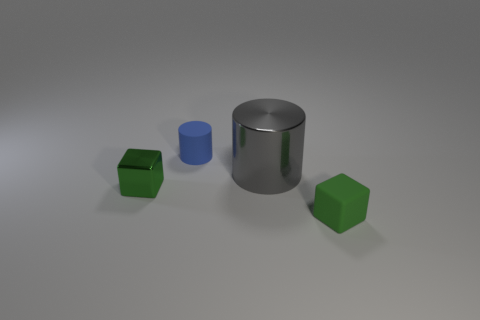Does the blue matte cylinder have the same size as the rubber block?
Give a very brief answer. Yes. There is a green object that is made of the same material as the large cylinder; what shape is it?
Your answer should be very brief. Cube. How many other objects are there of the same shape as the tiny blue object?
Your response must be concise. 1. What shape is the tiny green thing that is on the left side of the cube that is in front of the green block that is left of the big gray metallic cylinder?
Offer a terse response. Cube. How many balls are either small things or blue things?
Offer a very short reply. 0. There is a small cube that is to the right of the big metal object; is there a big gray metallic cylinder that is to the right of it?
Your answer should be very brief. No. Is there any other thing that is the same material as the gray cylinder?
Your answer should be very brief. Yes. There is a big thing; does it have the same shape as the tiny thing that is on the left side of the small rubber cylinder?
Provide a short and direct response. No. What number of other objects are the same size as the blue cylinder?
Make the answer very short. 2. How many red objects are either tiny rubber blocks or cylinders?
Your answer should be compact. 0. 